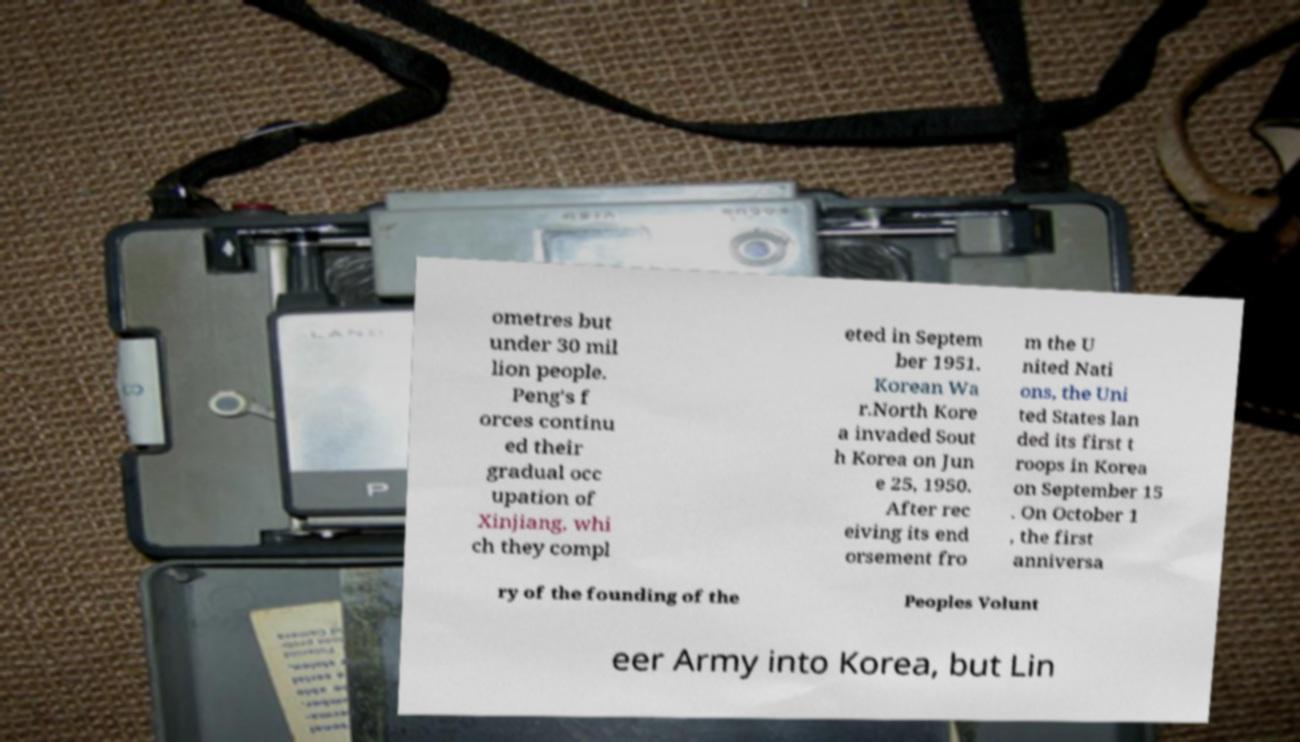There's text embedded in this image that I need extracted. Can you transcribe it verbatim? ometres but under 30 mil lion people. Peng's f orces continu ed their gradual occ upation of Xinjiang, whi ch they compl eted in Septem ber 1951. Korean Wa r.North Kore a invaded Sout h Korea on Jun e 25, 1950. After rec eiving its end orsement fro m the U nited Nati ons, the Uni ted States lan ded its first t roops in Korea on September 15 . On October 1 , the first anniversa ry of the founding of the Peoples Volunt eer Army into Korea, but Lin 